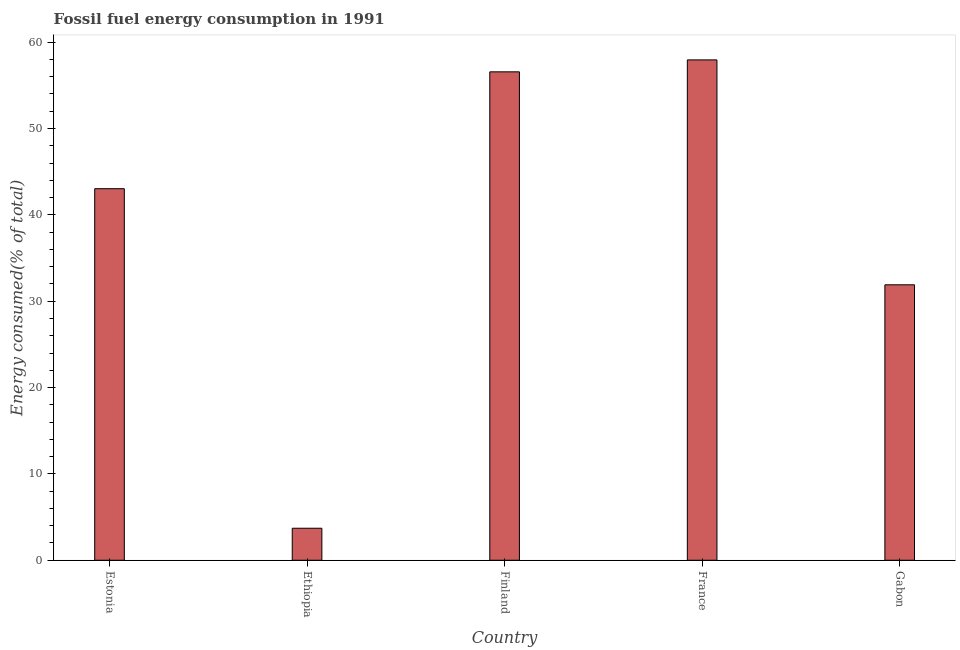Does the graph contain any zero values?
Provide a short and direct response. No. Does the graph contain grids?
Offer a very short reply. No. What is the title of the graph?
Provide a short and direct response. Fossil fuel energy consumption in 1991. What is the label or title of the X-axis?
Your response must be concise. Country. What is the label or title of the Y-axis?
Your answer should be compact. Energy consumed(% of total). What is the fossil fuel energy consumption in Finland?
Provide a succinct answer. 56.56. Across all countries, what is the maximum fossil fuel energy consumption?
Your answer should be very brief. 57.95. Across all countries, what is the minimum fossil fuel energy consumption?
Your answer should be very brief. 3.71. In which country was the fossil fuel energy consumption minimum?
Provide a succinct answer. Ethiopia. What is the sum of the fossil fuel energy consumption?
Your answer should be compact. 193.15. What is the difference between the fossil fuel energy consumption in Ethiopia and Finland?
Your response must be concise. -52.85. What is the average fossil fuel energy consumption per country?
Keep it short and to the point. 38.63. What is the median fossil fuel energy consumption?
Keep it short and to the point. 43.03. In how many countries, is the fossil fuel energy consumption greater than 22 %?
Ensure brevity in your answer.  4. What is the ratio of the fossil fuel energy consumption in Ethiopia to that in France?
Keep it short and to the point. 0.06. Is the fossil fuel energy consumption in Finland less than that in Gabon?
Keep it short and to the point. No. What is the difference between the highest and the second highest fossil fuel energy consumption?
Your answer should be compact. 1.38. Is the sum of the fossil fuel energy consumption in Estonia and Ethiopia greater than the maximum fossil fuel energy consumption across all countries?
Make the answer very short. No. What is the difference between the highest and the lowest fossil fuel energy consumption?
Ensure brevity in your answer.  54.24. In how many countries, is the fossil fuel energy consumption greater than the average fossil fuel energy consumption taken over all countries?
Make the answer very short. 3. Are all the bars in the graph horizontal?
Provide a short and direct response. No. What is the difference between two consecutive major ticks on the Y-axis?
Your answer should be compact. 10. Are the values on the major ticks of Y-axis written in scientific E-notation?
Your answer should be compact. No. What is the Energy consumed(% of total) in Estonia?
Make the answer very short. 43.03. What is the Energy consumed(% of total) in Ethiopia?
Ensure brevity in your answer.  3.71. What is the Energy consumed(% of total) in Finland?
Provide a short and direct response. 56.56. What is the Energy consumed(% of total) in France?
Give a very brief answer. 57.95. What is the Energy consumed(% of total) of Gabon?
Make the answer very short. 31.9. What is the difference between the Energy consumed(% of total) in Estonia and Ethiopia?
Offer a terse response. 39.32. What is the difference between the Energy consumed(% of total) in Estonia and Finland?
Your response must be concise. -13.53. What is the difference between the Energy consumed(% of total) in Estonia and France?
Your answer should be very brief. -14.92. What is the difference between the Energy consumed(% of total) in Estonia and Gabon?
Your answer should be very brief. 11.13. What is the difference between the Energy consumed(% of total) in Ethiopia and Finland?
Keep it short and to the point. -52.85. What is the difference between the Energy consumed(% of total) in Ethiopia and France?
Offer a terse response. -54.24. What is the difference between the Energy consumed(% of total) in Ethiopia and Gabon?
Offer a terse response. -28.19. What is the difference between the Energy consumed(% of total) in Finland and France?
Offer a terse response. -1.38. What is the difference between the Energy consumed(% of total) in Finland and Gabon?
Provide a succinct answer. 24.66. What is the difference between the Energy consumed(% of total) in France and Gabon?
Your answer should be compact. 26.05. What is the ratio of the Energy consumed(% of total) in Estonia to that in Ethiopia?
Give a very brief answer. 11.6. What is the ratio of the Energy consumed(% of total) in Estonia to that in Finland?
Your response must be concise. 0.76. What is the ratio of the Energy consumed(% of total) in Estonia to that in France?
Provide a short and direct response. 0.74. What is the ratio of the Energy consumed(% of total) in Estonia to that in Gabon?
Your response must be concise. 1.35. What is the ratio of the Energy consumed(% of total) in Ethiopia to that in Finland?
Give a very brief answer. 0.07. What is the ratio of the Energy consumed(% of total) in Ethiopia to that in France?
Keep it short and to the point. 0.06. What is the ratio of the Energy consumed(% of total) in Ethiopia to that in Gabon?
Keep it short and to the point. 0.12. What is the ratio of the Energy consumed(% of total) in Finland to that in Gabon?
Ensure brevity in your answer.  1.77. What is the ratio of the Energy consumed(% of total) in France to that in Gabon?
Keep it short and to the point. 1.82. 